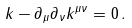Convert formula to latex. <formula><loc_0><loc_0><loc_500><loc_500>k - \partial _ { \mu } \partial _ { \nu } k ^ { \mu \nu } = 0 \, .</formula> 